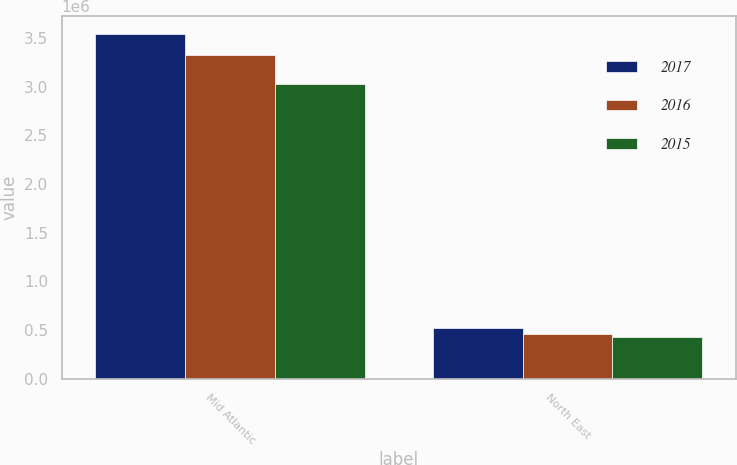Convert chart. <chart><loc_0><loc_0><loc_500><loc_500><stacked_bar_chart><ecel><fcel>Mid Atlantic<fcel>North East<nl><fcel>2017<fcel>3.54369e+06<fcel>517141<nl><fcel>2016<fcel>3.31978e+06<fcel>462385<nl><fcel>2015<fcel>3.02279e+06<fcel>432145<nl></chart> 